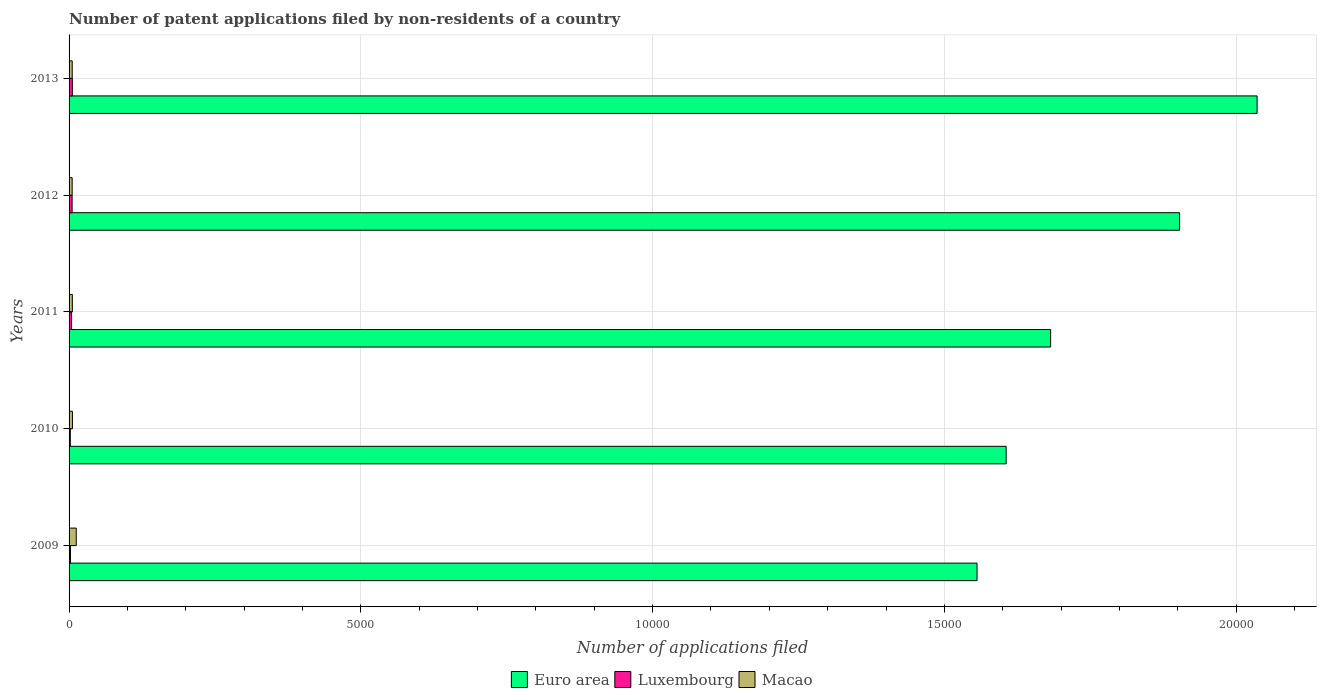How many different coloured bars are there?
Offer a terse response. 3. Are the number of bars per tick equal to the number of legend labels?
Keep it short and to the point. Yes. Are the number of bars on each tick of the Y-axis equal?
Offer a terse response. Yes. In how many cases, is the number of bars for a given year not equal to the number of legend labels?
Ensure brevity in your answer.  0. Across all years, what is the maximum number of applications filed in Euro area?
Offer a terse response. 2.04e+04. Across all years, what is the minimum number of applications filed in Euro area?
Offer a very short reply. 1.56e+04. In which year was the number of applications filed in Euro area minimum?
Offer a very short reply. 2009. What is the total number of applications filed in Macao in the graph?
Your answer should be compact. 344. What is the difference between the number of applications filed in Euro area in 2010 and that in 2012?
Provide a short and direct response. -2972. What is the difference between the number of applications filed in Euro area in 2009 and the number of applications filed in Luxembourg in 2012?
Provide a short and direct response. 1.55e+04. What is the average number of applications filed in Luxembourg per year?
Give a very brief answer. 39.2. In the year 2012, what is the difference between the number of applications filed in Euro area and number of applications filed in Luxembourg?
Provide a succinct answer. 1.90e+04. In how many years, is the number of applications filed in Euro area greater than 2000 ?
Ensure brevity in your answer.  5. What is the ratio of the number of applications filed in Macao in 2010 to that in 2013?
Give a very brief answer. 1.07. Is the number of applications filed in Euro area in 2009 less than that in 2013?
Offer a very short reply. Yes. Is the difference between the number of applications filed in Euro area in 2009 and 2010 greater than the difference between the number of applications filed in Luxembourg in 2009 and 2010?
Provide a short and direct response. No. What is the difference between the highest and the lowest number of applications filed in Euro area?
Offer a very short reply. 4799. Is the sum of the number of applications filed in Luxembourg in 2009 and 2012 greater than the maximum number of applications filed in Macao across all years?
Your answer should be very brief. No. What does the 1st bar from the top in 2011 represents?
Ensure brevity in your answer.  Macao. Is it the case that in every year, the sum of the number of applications filed in Luxembourg and number of applications filed in Euro area is greater than the number of applications filed in Macao?
Your answer should be compact. Yes. Are all the bars in the graph horizontal?
Your answer should be compact. Yes. What is the difference between two consecutive major ticks on the X-axis?
Make the answer very short. 5000. Does the graph contain any zero values?
Make the answer very short. No. Does the graph contain grids?
Provide a short and direct response. Yes. How many legend labels are there?
Offer a very short reply. 3. What is the title of the graph?
Your response must be concise. Number of patent applications filed by non-residents of a country. What is the label or title of the X-axis?
Provide a succinct answer. Number of applications filed. What is the Number of applications filed in Euro area in 2009?
Offer a very short reply. 1.56e+04. What is the Number of applications filed of Luxembourg in 2009?
Your response must be concise. 24. What is the Number of applications filed in Macao in 2009?
Provide a short and direct response. 123. What is the Number of applications filed of Euro area in 2010?
Provide a succinct answer. 1.61e+04. What is the Number of applications filed of Luxembourg in 2010?
Your answer should be compact. 21. What is the Number of applications filed in Euro area in 2011?
Your answer should be compact. 1.68e+04. What is the Number of applications filed of Euro area in 2012?
Provide a succinct answer. 1.90e+04. What is the Number of applications filed in Luxembourg in 2012?
Offer a terse response. 52. What is the Number of applications filed of Macao in 2012?
Offer a terse response. 53. What is the Number of applications filed of Euro area in 2013?
Give a very brief answer. 2.04e+04. What is the Number of applications filed of Macao in 2013?
Your answer should be very brief. 54. Across all years, what is the maximum Number of applications filed in Euro area?
Ensure brevity in your answer.  2.04e+04. Across all years, what is the maximum Number of applications filed of Luxembourg?
Ensure brevity in your answer.  56. Across all years, what is the maximum Number of applications filed in Macao?
Your answer should be very brief. 123. Across all years, what is the minimum Number of applications filed in Euro area?
Provide a short and direct response. 1.56e+04. Across all years, what is the minimum Number of applications filed in Macao?
Your answer should be very brief. 53. What is the total Number of applications filed of Euro area in the graph?
Provide a succinct answer. 8.78e+04. What is the total Number of applications filed of Luxembourg in the graph?
Keep it short and to the point. 196. What is the total Number of applications filed of Macao in the graph?
Keep it short and to the point. 344. What is the difference between the Number of applications filed of Euro area in 2009 and that in 2010?
Keep it short and to the point. -499. What is the difference between the Number of applications filed in Euro area in 2009 and that in 2011?
Keep it short and to the point. -1261. What is the difference between the Number of applications filed in Euro area in 2009 and that in 2012?
Provide a short and direct response. -3471. What is the difference between the Number of applications filed in Luxembourg in 2009 and that in 2012?
Your response must be concise. -28. What is the difference between the Number of applications filed in Euro area in 2009 and that in 2013?
Offer a very short reply. -4799. What is the difference between the Number of applications filed in Luxembourg in 2009 and that in 2013?
Your answer should be very brief. -32. What is the difference between the Number of applications filed in Macao in 2009 and that in 2013?
Your answer should be compact. 69. What is the difference between the Number of applications filed of Euro area in 2010 and that in 2011?
Offer a terse response. -762. What is the difference between the Number of applications filed in Luxembourg in 2010 and that in 2011?
Your response must be concise. -22. What is the difference between the Number of applications filed of Macao in 2010 and that in 2011?
Provide a short and direct response. 2. What is the difference between the Number of applications filed of Euro area in 2010 and that in 2012?
Keep it short and to the point. -2972. What is the difference between the Number of applications filed of Luxembourg in 2010 and that in 2012?
Provide a succinct answer. -31. What is the difference between the Number of applications filed of Euro area in 2010 and that in 2013?
Keep it short and to the point. -4300. What is the difference between the Number of applications filed of Luxembourg in 2010 and that in 2013?
Offer a very short reply. -35. What is the difference between the Number of applications filed in Euro area in 2011 and that in 2012?
Provide a succinct answer. -2210. What is the difference between the Number of applications filed in Macao in 2011 and that in 2012?
Keep it short and to the point. 3. What is the difference between the Number of applications filed in Euro area in 2011 and that in 2013?
Provide a short and direct response. -3538. What is the difference between the Number of applications filed of Macao in 2011 and that in 2013?
Ensure brevity in your answer.  2. What is the difference between the Number of applications filed of Euro area in 2012 and that in 2013?
Your answer should be very brief. -1328. What is the difference between the Number of applications filed of Macao in 2012 and that in 2013?
Your response must be concise. -1. What is the difference between the Number of applications filed of Euro area in 2009 and the Number of applications filed of Luxembourg in 2010?
Give a very brief answer. 1.55e+04. What is the difference between the Number of applications filed in Euro area in 2009 and the Number of applications filed in Macao in 2010?
Your response must be concise. 1.55e+04. What is the difference between the Number of applications filed in Luxembourg in 2009 and the Number of applications filed in Macao in 2010?
Offer a terse response. -34. What is the difference between the Number of applications filed in Euro area in 2009 and the Number of applications filed in Luxembourg in 2011?
Your response must be concise. 1.55e+04. What is the difference between the Number of applications filed of Euro area in 2009 and the Number of applications filed of Macao in 2011?
Offer a terse response. 1.55e+04. What is the difference between the Number of applications filed in Luxembourg in 2009 and the Number of applications filed in Macao in 2011?
Keep it short and to the point. -32. What is the difference between the Number of applications filed of Euro area in 2009 and the Number of applications filed of Luxembourg in 2012?
Make the answer very short. 1.55e+04. What is the difference between the Number of applications filed in Euro area in 2009 and the Number of applications filed in Macao in 2012?
Give a very brief answer. 1.55e+04. What is the difference between the Number of applications filed of Euro area in 2009 and the Number of applications filed of Luxembourg in 2013?
Ensure brevity in your answer.  1.55e+04. What is the difference between the Number of applications filed of Euro area in 2009 and the Number of applications filed of Macao in 2013?
Offer a terse response. 1.55e+04. What is the difference between the Number of applications filed of Euro area in 2010 and the Number of applications filed of Luxembourg in 2011?
Provide a short and direct response. 1.60e+04. What is the difference between the Number of applications filed of Euro area in 2010 and the Number of applications filed of Macao in 2011?
Offer a very short reply. 1.60e+04. What is the difference between the Number of applications filed of Luxembourg in 2010 and the Number of applications filed of Macao in 2011?
Offer a very short reply. -35. What is the difference between the Number of applications filed of Euro area in 2010 and the Number of applications filed of Luxembourg in 2012?
Provide a short and direct response. 1.60e+04. What is the difference between the Number of applications filed of Euro area in 2010 and the Number of applications filed of Macao in 2012?
Ensure brevity in your answer.  1.60e+04. What is the difference between the Number of applications filed in Luxembourg in 2010 and the Number of applications filed in Macao in 2012?
Offer a terse response. -32. What is the difference between the Number of applications filed of Euro area in 2010 and the Number of applications filed of Luxembourg in 2013?
Your response must be concise. 1.60e+04. What is the difference between the Number of applications filed of Euro area in 2010 and the Number of applications filed of Macao in 2013?
Make the answer very short. 1.60e+04. What is the difference between the Number of applications filed of Luxembourg in 2010 and the Number of applications filed of Macao in 2013?
Your response must be concise. -33. What is the difference between the Number of applications filed in Euro area in 2011 and the Number of applications filed in Luxembourg in 2012?
Your response must be concise. 1.68e+04. What is the difference between the Number of applications filed of Euro area in 2011 and the Number of applications filed of Macao in 2012?
Keep it short and to the point. 1.68e+04. What is the difference between the Number of applications filed in Euro area in 2011 and the Number of applications filed in Luxembourg in 2013?
Your response must be concise. 1.68e+04. What is the difference between the Number of applications filed of Euro area in 2011 and the Number of applications filed of Macao in 2013?
Give a very brief answer. 1.68e+04. What is the difference between the Number of applications filed in Euro area in 2012 and the Number of applications filed in Luxembourg in 2013?
Keep it short and to the point. 1.90e+04. What is the difference between the Number of applications filed of Euro area in 2012 and the Number of applications filed of Macao in 2013?
Provide a succinct answer. 1.90e+04. What is the difference between the Number of applications filed in Luxembourg in 2012 and the Number of applications filed in Macao in 2013?
Your response must be concise. -2. What is the average Number of applications filed of Euro area per year?
Your answer should be compact. 1.76e+04. What is the average Number of applications filed of Luxembourg per year?
Give a very brief answer. 39.2. What is the average Number of applications filed in Macao per year?
Offer a very short reply. 68.8. In the year 2009, what is the difference between the Number of applications filed in Euro area and Number of applications filed in Luxembourg?
Your answer should be compact. 1.55e+04. In the year 2009, what is the difference between the Number of applications filed in Euro area and Number of applications filed in Macao?
Your answer should be compact. 1.54e+04. In the year 2009, what is the difference between the Number of applications filed in Luxembourg and Number of applications filed in Macao?
Give a very brief answer. -99. In the year 2010, what is the difference between the Number of applications filed in Euro area and Number of applications filed in Luxembourg?
Your answer should be compact. 1.60e+04. In the year 2010, what is the difference between the Number of applications filed of Euro area and Number of applications filed of Macao?
Your response must be concise. 1.60e+04. In the year 2010, what is the difference between the Number of applications filed of Luxembourg and Number of applications filed of Macao?
Provide a short and direct response. -37. In the year 2011, what is the difference between the Number of applications filed in Euro area and Number of applications filed in Luxembourg?
Offer a terse response. 1.68e+04. In the year 2011, what is the difference between the Number of applications filed of Euro area and Number of applications filed of Macao?
Offer a very short reply. 1.68e+04. In the year 2012, what is the difference between the Number of applications filed in Euro area and Number of applications filed in Luxembourg?
Your answer should be very brief. 1.90e+04. In the year 2012, what is the difference between the Number of applications filed of Euro area and Number of applications filed of Macao?
Provide a succinct answer. 1.90e+04. In the year 2012, what is the difference between the Number of applications filed in Luxembourg and Number of applications filed in Macao?
Your answer should be very brief. -1. In the year 2013, what is the difference between the Number of applications filed in Euro area and Number of applications filed in Luxembourg?
Keep it short and to the point. 2.03e+04. In the year 2013, what is the difference between the Number of applications filed of Euro area and Number of applications filed of Macao?
Ensure brevity in your answer.  2.03e+04. In the year 2013, what is the difference between the Number of applications filed in Luxembourg and Number of applications filed in Macao?
Offer a terse response. 2. What is the ratio of the Number of applications filed in Euro area in 2009 to that in 2010?
Your answer should be very brief. 0.97. What is the ratio of the Number of applications filed in Macao in 2009 to that in 2010?
Keep it short and to the point. 2.12. What is the ratio of the Number of applications filed in Euro area in 2009 to that in 2011?
Offer a terse response. 0.93. What is the ratio of the Number of applications filed of Luxembourg in 2009 to that in 2011?
Your answer should be very brief. 0.56. What is the ratio of the Number of applications filed of Macao in 2009 to that in 2011?
Offer a terse response. 2.2. What is the ratio of the Number of applications filed of Euro area in 2009 to that in 2012?
Ensure brevity in your answer.  0.82. What is the ratio of the Number of applications filed of Luxembourg in 2009 to that in 2012?
Offer a very short reply. 0.46. What is the ratio of the Number of applications filed in Macao in 2009 to that in 2012?
Your answer should be compact. 2.32. What is the ratio of the Number of applications filed in Euro area in 2009 to that in 2013?
Give a very brief answer. 0.76. What is the ratio of the Number of applications filed of Luxembourg in 2009 to that in 2013?
Offer a very short reply. 0.43. What is the ratio of the Number of applications filed of Macao in 2009 to that in 2013?
Your answer should be compact. 2.28. What is the ratio of the Number of applications filed in Euro area in 2010 to that in 2011?
Your response must be concise. 0.95. What is the ratio of the Number of applications filed of Luxembourg in 2010 to that in 2011?
Offer a terse response. 0.49. What is the ratio of the Number of applications filed in Macao in 2010 to that in 2011?
Give a very brief answer. 1.04. What is the ratio of the Number of applications filed in Euro area in 2010 to that in 2012?
Provide a short and direct response. 0.84. What is the ratio of the Number of applications filed in Luxembourg in 2010 to that in 2012?
Offer a very short reply. 0.4. What is the ratio of the Number of applications filed of Macao in 2010 to that in 2012?
Keep it short and to the point. 1.09. What is the ratio of the Number of applications filed of Euro area in 2010 to that in 2013?
Offer a very short reply. 0.79. What is the ratio of the Number of applications filed of Luxembourg in 2010 to that in 2013?
Keep it short and to the point. 0.38. What is the ratio of the Number of applications filed of Macao in 2010 to that in 2013?
Offer a very short reply. 1.07. What is the ratio of the Number of applications filed of Euro area in 2011 to that in 2012?
Offer a terse response. 0.88. What is the ratio of the Number of applications filed in Luxembourg in 2011 to that in 2012?
Your response must be concise. 0.83. What is the ratio of the Number of applications filed in Macao in 2011 to that in 2012?
Offer a terse response. 1.06. What is the ratio of the Number of applications filed in Euro area in 2011 to that in 2013?
Ensure brevity in your answer.  0.83. What is the ratio of the Number of applications filed of Luxembourg in 2011 to that in 2013?
Offer a very short reply. 0.77. What is the ratio of the Number of applications filed in Euro area in 2012 to that in 2013?
Offer a very short reply. 0.93. What is the ratio of the Number of applications filed in Luxembourg in 2012 to that in 2013?
Give a very brief answer. 0.93. What is the ratio of the Number of applications filed of Macao in 2012 to that in 2013?
Provide a short and direct response. 0.98. What is the difference between the highest and the second highest Number of applications filed in Euro area?
Offer a very short reply. 1328. What is the difference between the highest and the second highest Number of applications filed of Luxembourg?
Give a very brief answer. 4. What is the difference between the highest and the lowest Number of applications filed in Euro area?
Make the answer very short. 4799. What is the difference between the highest and the lowest Number of applications filed in Luxembourg?
Offer a very short reply. 35. What is the difference between the highest and the lowest Number of applications filed of Macao?
Your answer should be very brief. 70. 